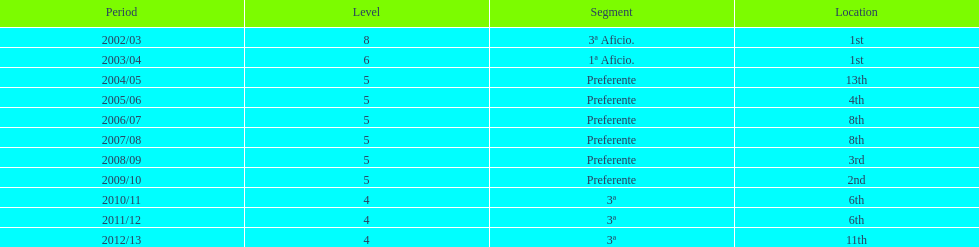Which division has the largest number of ranks? Preferente. Would you be able to parse every entry in this table? {'header': ['Period', 'Level', 'Segment', 'Location'], 'rows': [['2002/03', '8', '3ª Aficio.', '1st'], ['2003/04', '6', '1ª Aficio.', '1st'], ['2004/05', '5', 'Preferente', '13th'], ['2005/06', '5', 'Preferente', '4th'], ['2006/07', '5', 'Preferente', '8th'], ['2007/08', '5', 'Preferente', '8th'], ['2008/09', '5', 'Preferente', '3rd'], ['2009/10', '5', 'Preferente', '2nd'], ['2010/11', '4', '3ª', '6th'], ['2011/12', '4', '3ª', '6th'], ['2012/13', '4', '3ª', '11th']]} 